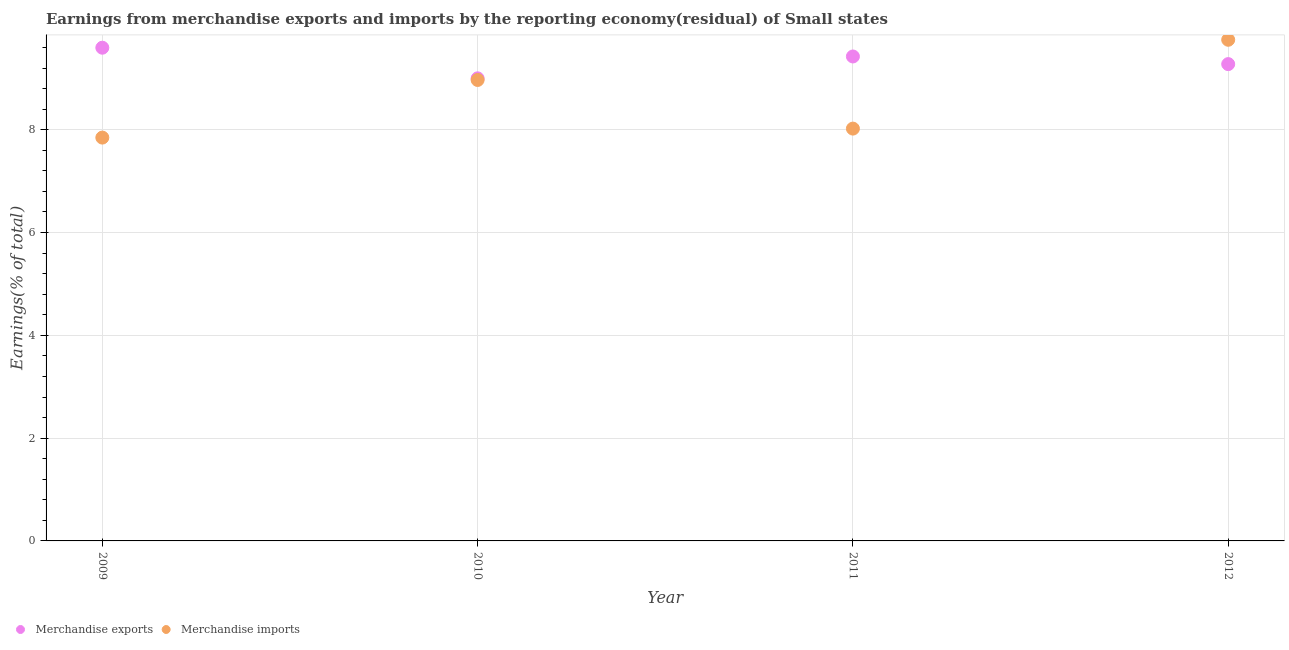How many different coloured dotlines are there?
Make the answer very short. 2. Is the number of dotlines equal to the number of legend labels?
Make the answer very short. Yes. What is the earnings from merchandise exports in 2010?
Offer a very short reply. 9. Across all years, what is the maximum earnings from merchandise exports?
Ensure brevity in your answer.  9.6. Across all years, what is the minimum earnings from merchandise imports?
Provide a short and direct response. 7.85. In which year was the earnings from merchandise imports minimum?
Your response must be concise. 2009. What is the total earnings from merchandise exports in the graph?
Ensure brevity in your answer.  37.3. What is the difference between the earnings from merchandise imports in 2011 and that in 2012?
Offer a very short reply. -1.73. What is the difference between the earnings from merchandise imports in 2012 and the earnings from merchandise exports in 2009?
Your answer should be compact. 0.15. What is the average earnings from merchandise exports per year?
Provide a short and direct response. 9.32. In the year 2010, what is the difference between the earnings from merchandise exports and earnings from merchandise imports?
Provide a succinct answer. 0.03. What is the ratio of the earnings from merchandise imports in 2010 to that in 2012?
Your answer should be compact. 0.92. Is the earnings from merchandise exports in 2010 less than that in 2012?
Offer a very short reply. Yes. What is the difference between the highest and the second highest earnings from merchandise imports?
Provide a short and direct response. 0.78. What is the difference between the highest and the lowest earnings from merchandise exports?
Make the answer very short. 0.6. In how many years, is the earnings from merchandise exports greater than the average earnings from merchandise exports taken over all years?
Provide a succinct answer. 2. Is the sum of the earnings from merchandise imports in 2010 and 2012 greater than the maximum earnings from merchandise exports across all years?
Provide a short and direct response. Yes. Does the earnings from merchandise imports monotonically increase over the years?
Provide a short and direct response. No. Is the earnings from merchandise imports strictly greater than the earnings from merchandise exports over the years?
Keep it short and to the point. No. Is the earnings from merchandise imports strictly less than the earnings from merchandise exports over the years?
Ensure brevity in your answer.  No. How many years are there in the graph?
Ensure brevity in your answer.  4. What is the difference between two consecutive major ticks on the Y-axis?
Offer a very short reply. 2. Are the values on the major ticks of Y-axis written in scientific E-notation?
Offer a terse response. No. Where does the legend appear in the graph?
Offer a terse response. Bottom left. How are the legend labels stacked?
Give a very brief answer. Horizontal. What is the title of the graph?
Your answer should be very brief. Earnings from merchandise exports and imports by the reporting economy(residual) of Small states. Does "Secondary education" appear as one of the legend labels in the graph?
Offer a very short reply. No. What is the label or title of the X-axis?
Provide a short and direct response. Year. What is the label or title of the Y-axis?
Ensure brevity in your answer.  Earnings(% of total). What is the Earnings(% of total) in Merchandise exports in 2009?
Make the answer very short. 9.6. What is the Earnings(% of total) of Merchandise imports in 2009?
Your answer should be very brief. 7.85. What is the Earnings(% of total) in Merchandise exports in 2010?
Your answer should be very brief. 9. What is the Earnings(% of total) of Merchandise imports in 2010?
Your response must be concise. 8.97. What is the Earnings(% of total) in Merchandise exports in 2011?
Offer a very short reply. 9.43. What is the Earnings(% of total) of Merchandise imports in 2011?
Offer a very short reply. 8.02. What is the Earnings(% of total) of Merchandise exports in 2012?
Keep it short and to the point. 9.28. What is the Earnings(% of total) of Merchandise imports in 2012?
Your answer should be compact. 9.75. Across all years, what is the maximum Earnings(% of total) of Merchandise exports?
Your answer should be compact. 9.6. Across all years, what is the maximum Earnings(% of total) in Merchandise imports?
Offer a very short reply. 9.75. Across all years, what is the minimum Earnings(% of total) in Merchandise exports?
Offer a terse response. 9. Across all years, what is the minimum Earnings(% of total) in Merchandise imports?
Offer a very short reply. 7.85. What is the total Earnings(% of total) of Merchandise exports in the graph?
Provide a succinct answer. 37.3. What is the total Earnings(% of total) of Merchandise imports in the graph?
Keep it short and to the point. 34.59. What is the difference between the Earnings(% of total) in Merchandise exports in 2009 and that in 2010?
Offer a very short reply. 0.6. What is the difference between the Earnings(% of total) of Merchandise imports in 2009 and that in 2010?
Your answer should be very brief. -1.12. What is the difference between the Earnings(% of total) in Merchandise exports in 2009 and that in 2011?
Keep it short and to the point. 0.17. What is the difference between the Earnings(% of total) of Merchandise imports in 2009 and that in 2011?
Provide a succinct answer. -0.17. What is the difference between the Earnings(% of total) of Merchandise exports in 2009 and that in 2012?
Provide a succinct answer. 0.32. What is the difference between the Earnings(% of total) of Merchandise imports in 2009 and that in 2012?
Your response must be concise. -1.9. What is the difference between the Earnings(% of total) of Merchandise exports in 2010 and that in 2011?
Provide a short and direct response. -0.43. What is the difference between the Earnings(% of total) of Merchandise imports in 2010 and that in 2011?
Your answer should be very brief. 0.95. What is the difference between the Earnings(% of total) of Merchandise exports in 2010 and that in 2012?
Offer a terse response. -0.28. What is the difference between the Earnings(% of total) in Merchandise imports in 2010 and that in 2012?
Offer a terse response. -0.78. What is the difference between the Earnings(% of total) of Merchandise exports in 2011 and that in 2012?
Your response must be concise. 0.15. What is the difference between the Earnings(% of total) of Merchandise imports in 2011 and that in 2012?
Keep it short and to the point. -1.73. What is the difference between the Earnings(% of total) of Merchandise exports in 2009 and the Earnings(% of total) of Merchandise imports in 2010?
Offer a very short reply. 0.63. What is the difference between the Earnings(% of total) of Merchandise exports in 2009 and the Earnings(% of total) of Merchandise imports in 2011?
Your answer should be compact. 1.57. What is the difference between the Earnings(% of total) in Merchandise exports in 2009 and the Earnings(% of total) in Merchandise imports in 2012?
Your answer should be very brief. -0.15. What is the difference between the Earnings(% of total) in Merchandise exports in 2010 and the Earnings(% of total) in Merchandise imports in 2011?
Provide a short and direct response. 0.98. What is the difference between the Earnings(% of total) of Merchandise exports in 2010 and the Earnings(% of total) of Merchandise imports in 2012?
Offer a very short reply. -0.75. What is the difference between the Earnings(% of total) in Merchandise exports in 2011 and the Earnings(% of total) in Merchandise imports in 2012?
Provide a short and direct response. -0.33. What is the average Earnings(% of total) in Merchandise exports per year?
Provide a short and direct response. 9.32. What is the average Earnings(% of total) of Merchandise imports per year?
Ensure brevity in your answer.  8.65. In the year 2009, what is the difference between the Earnings(% of total) in Merchandise exports and Earnings(% of total) in Merchandise imports?
Your answer should be compact. 1.75. In the year 2010, what is the difference between the Earnings(% of total) in Merchandise exports and Earnings(% of total) in Merchandise imports?
Your response must be concise. 0.03. In the year 2011, what is the difference between the Earnings(% of total) in Merchandise exports and Earnings(% of total) in Merchandise imports?
Make the answer very short. 1.4. In the year 2012, what is the difference between the Earnings(% of total) in Merchandise exports and Earnings(% of total) in Merchandise imports?
Keep it short and to the point. -0.47. What is the ratio of the Earnings(% of total) of Merchandise exports in 2009 to that in 2010?
Provide a short and direct response. 1.07. What is the ratio of the Earnings(% of total) of Merchandise exports in 2009 to that in 2011?
Your response must be concise. 1.02. What is the ratio of the Earnings(% of total) in Merchandise imports in 2009 to that in 2011?
Give a very brief answer. 0.98. What is the ratio of the Earnings(% of total) in Merchandise exports in 2009 to that in 2012?
Make the answer very short. 1.03. What is the ratio of the Earnings(% of total) of Merchandise imports in 2009 to that in 2012?
Give a very brief answer. 0.8. What is the ratio of the Earnings(% of total) in Merchandise exports in 2010 to that in 2011?
Your answer should be compact. 0.95. What is the ratio of the Earnings(% of total) in Merchandise imports in 2010 to that in 2011?
Make the answer very short. 1.12. What is the ratio of the Earnings(% of total) in Merchandise exports in 2010 to that in 2012?
Offer a terse response. 0.97. What is the ratio of the Earnings(% of total) in Merchandise imports in 2010 to that in 2012?
Make the answer very short. 0.92. What is the ratio of the Earnings(% of total) of Merchandise imports in 2011 to that in 2012?
Your answer should be very brief. 0.82. What is the difference between the highest and the second highest Earnings(% of total) of Merchandise exports?
Give a very brief answer. 0.17. What is the difference between the highest and the second highest Earnings(% of total) of Merchandise imports?
Provide a succinct answer. 0.78. What is the difference between the highest and the lowest Earnings(% of total) of Merchandise exports?
Give a very brief answer. 0.6. What is the difference between the highest and the lowest Earnings(% of total) of Merchandise imports?
Give a very brief answer. 1.9. 